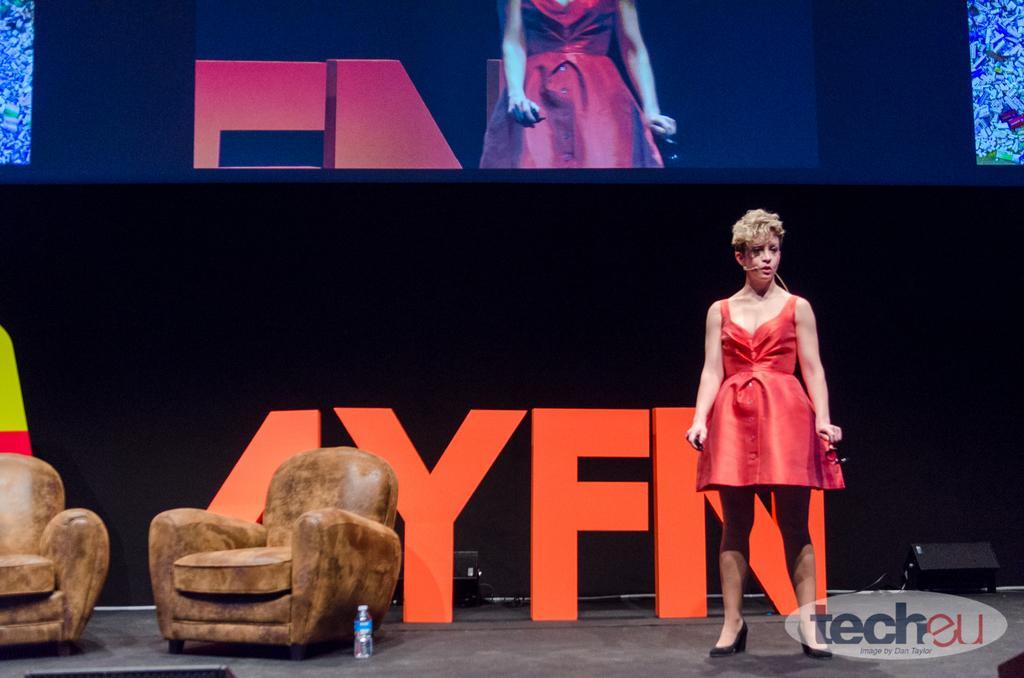How would you summarize this image in a sentence or two? I can see a woman standing wearing a red frock. There are two couch chairs. This is a water bottle placed on the floor. At the background I can see the screen where the display is. These are the letters placed on the stage. 